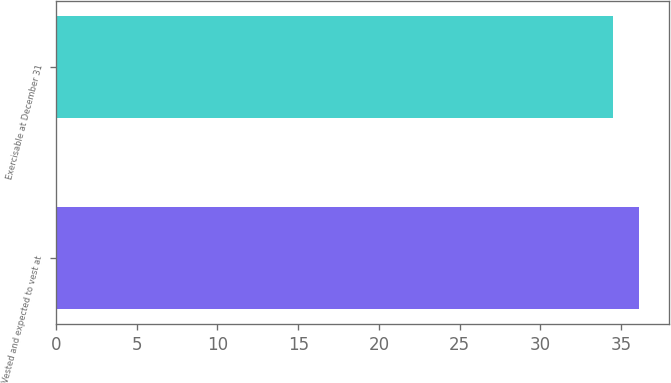Convert chart. <chart><loc_0><loc_0><loc_500><loc_500><bar_chart><fcel>Vested and expected to vest at<fcel>Exercisable at December 31<nl><fcel>36.14<fcel>34.48<nl></chart> 